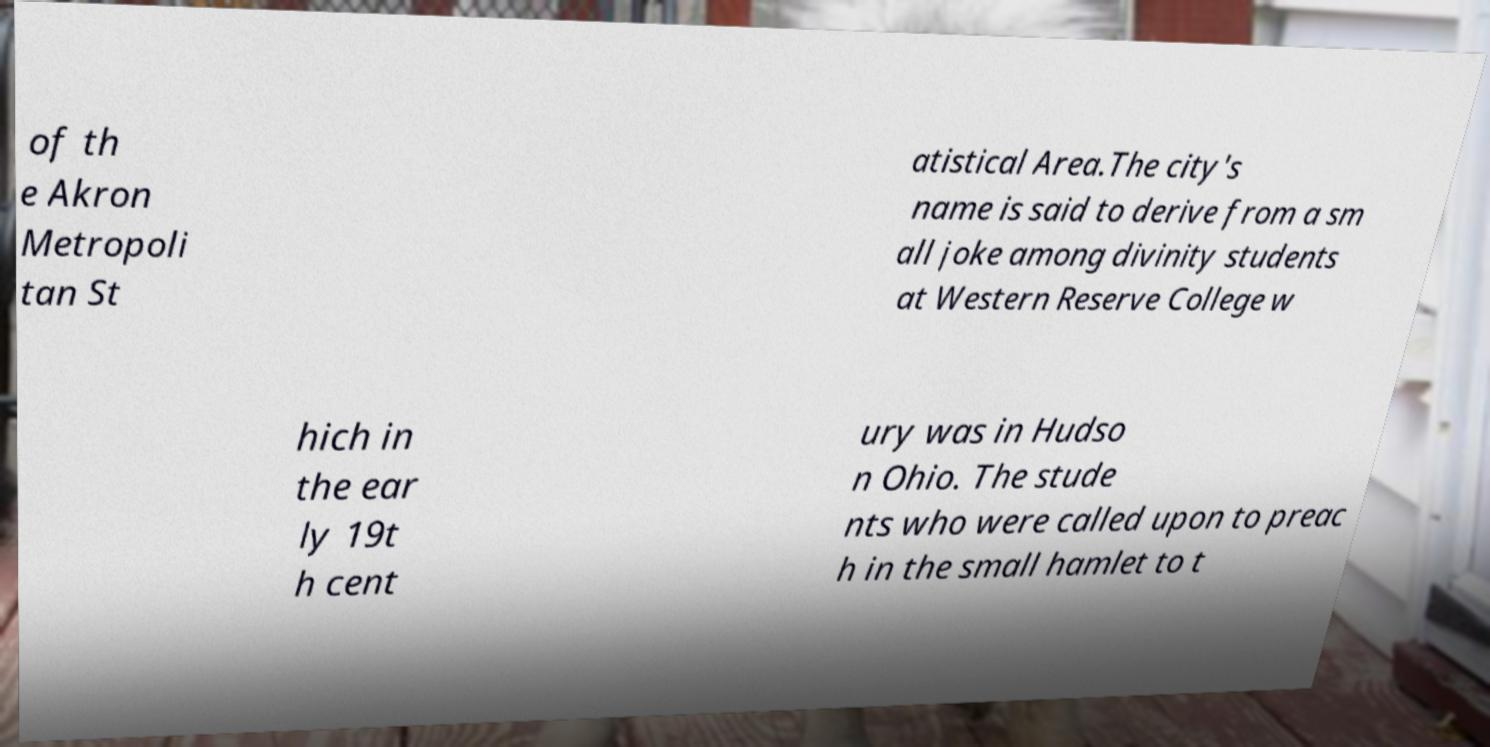Can you accurately transcribe the text from the provided image for me? of th e Akron Metropoli tan St atistical Area.The city's name is said to derive from a sm all joke among divinity students at Western Reserve College w hich in the ear ly 19t h cent ury was in Hudso n Ohio. The stude nts who were called upon to preac h in the small hamlet to t 